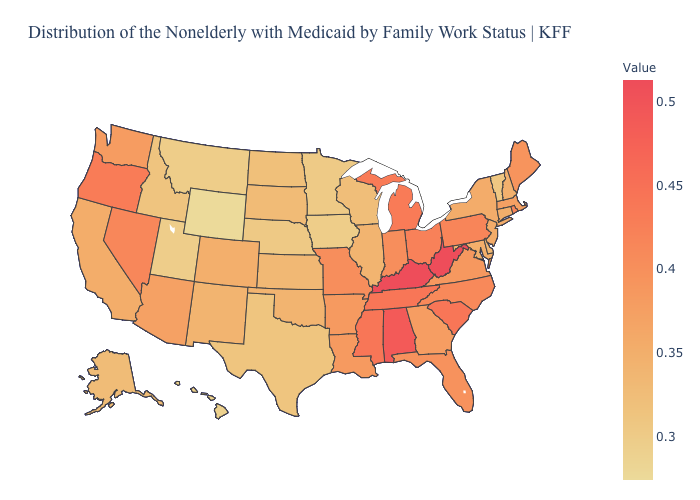Which states have the highest value in the USA?
Concise answer only. Kentucky, West Virginia. Among the states that border Delaware , which have the highest value?
Short answer required. Pennsylvania. Does the map have missing data?
Concise answer only. No. Does South Carolina have a lower value than West Virginia?
Give a very brief answer. Yes. 